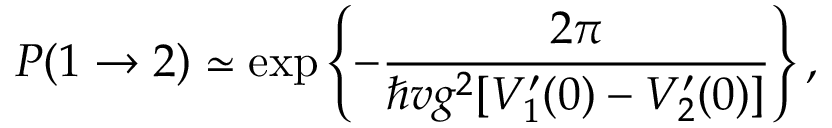Convert formula to latex. <formula><loc_0><loc_0><loc_500><loc_500>P ( 1 \rightarrow 2 ) \simeq \exp \left \{ - { \frac { 2 \pi } { \hbar { v } g ^ { 2 } [ V _ { 1 } ^ { \prime } ( 0 ) - V _ { 2 } ^ { \prime } ( 0 ) ] } } \right \} ,</formula> 